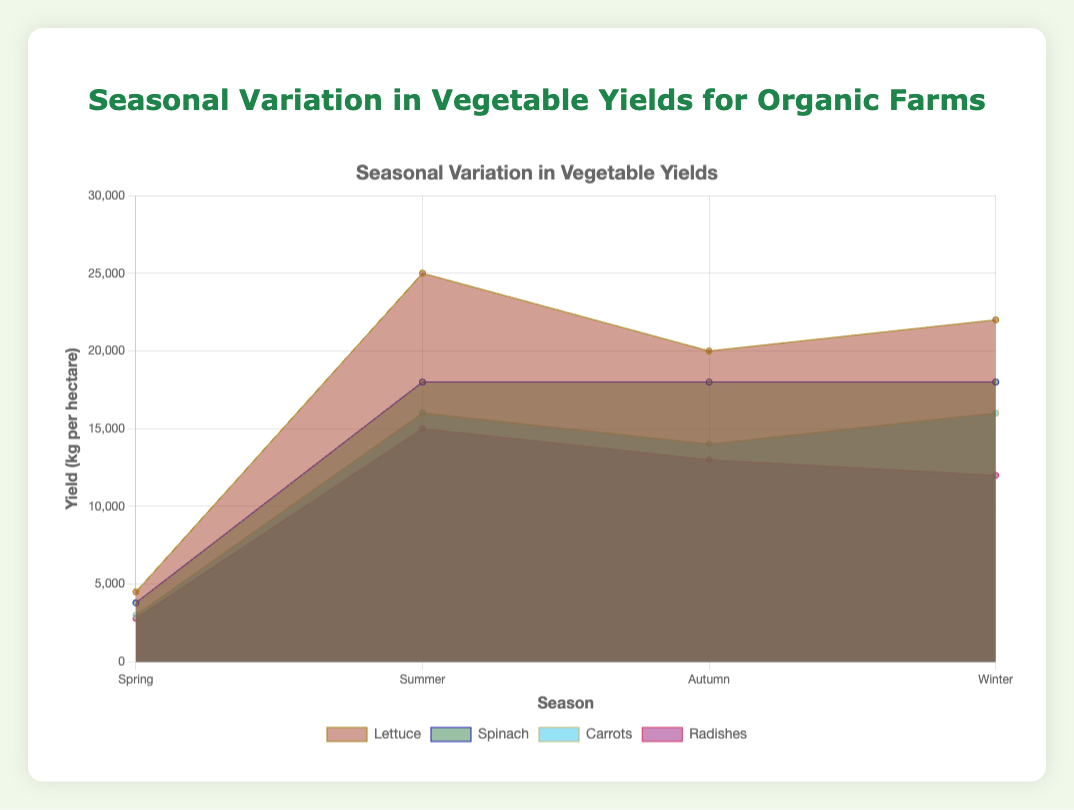What is the overall title of the figure? The title of the figure is usually displayed at the top and is essential for understanding the context of the data.
Answer: Seasonal Variation in Vegetable Yields for Organic Farms Which vegetable has the highest yield in Summer? By examining the figure, we observe the data points for the Summer season and identify the vegetable with the most significant yield value.
Answer: Tomatoes What are the vegetables displayed for the Winter season, and what are their yields? Look for the data points labeled "Winter" and list each vegetable along with its corresponding yield as shown by the area chart.
Answer: Cabbage: 22000 kg per hectare, Cauliflower: 18000 kg per hectare, Brussels Sprouts: 16000 kg per hectare, Leeks: 12000 kg per hectare Which season shows the highest yield for Broccoli? To determine this, locate the data points for Broccoli across all seasons and compare them. The highest point indicates the season with the highest yield.
Answer: Autumn What is the overall trend for Cabbage yields across the four seasons? Trace the data points for Cabbage through all the seasons and describe the noticeable trend in yields.
Answer: Increases in Winter Between Radishes and Carrots in Spring, which has a lower yield and by how much? Identify the yield value for Radishes and Carrots in Spring and subtract the smaller yield from the larger one.
Answer: Radishes have a lower yield by 200 kg per hectare Which vegetable maintains a relatively stable yield throughout the year? Identify a vegetable whose data points do not show significant fluctuations across the four seasons.
Answer: Spinach Compare the yield of Pumpkins in Autumn to Cabbage in Winter. Which is higher? Locate the yield values for Pumpkins in Autumn and Cabbage in Winter, then compare the two to determine which is greater.
Answer: Pumpkins What is the sum of the yields of all vegetables in the Autumn season? Add the yields of Pumpkins, Squash, Broccoli, and Kale in the Autumn season.
Answer: 65000 kg per hectare What differences are observed in vegetable yields between Spring and Summer seasons? Compare the data points of vegetables in Spring with those in Summer and describe the general differences in yields.
Answer: Summer yields are substantially higher 